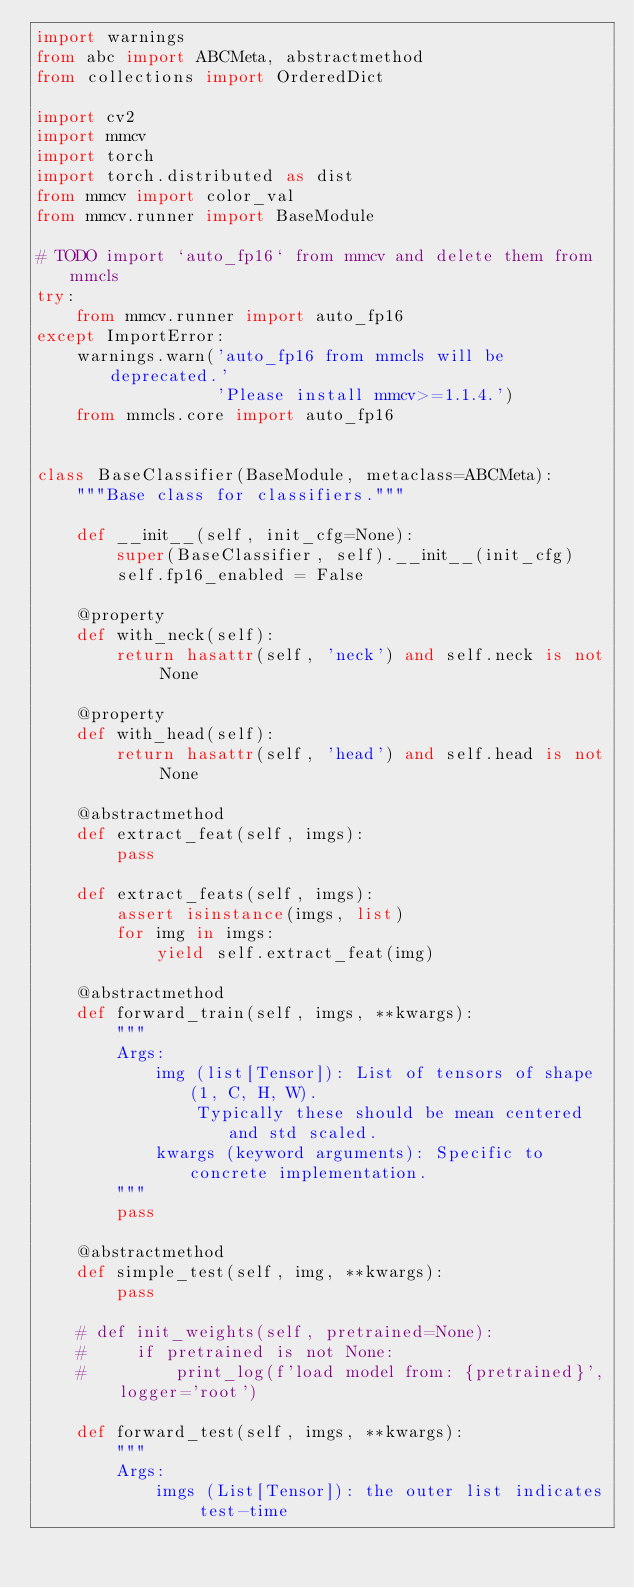<code> <loc_0><loc_0><loc_500><loc_500><_Python_>import warnings
from abc import ABCMeta, abstractmethod
from collections import OrderedDict

import cv2
import mmcv
import torch
import torch.distributed as dist
from mmcv import color_val
from mmcv.runner import BaseModule

# TODO import `auto_fp16` from mmcv and delete them from mmcls
try:
    from mmcv.runner import auto_fp16
except ImportError:
    warnings.warn('auto_fp16 from mmcls will be deprecated.'
                  'Please install mmcv>=1.1.4.')
    from mmcls.core import auto_fp16


class BaseClassifier(BaseModule, metaclass=ABCMeta):
    """Base class for classifiers."""

    def __init__(self, init_cfg=None):
        super(BaseClassifier, self).__init__(init_cfg)
        self.fp16_enabled = False

    @property
    def with_neck(self):
        return hasattr(self, 'neck') and self.neck is not None

    @property
    def with_head(self):
        return hasattr(self, 'head') and self.head is not None

    @abstractmethod
    def extract_feat(self, imgs):
        pass

    def extract_feats(self, imgs):
        assert isinstance(imgs, list)
        for img in imgs:
            yield self.extract_feat(img)

    @abstractmethod
    def forward_train(self, imgs, **kwargs):
        """
        Args:
            img (list[Tensor]): List of tensors of shape (1, C, H, W).
                Typically these should be mean centered and std scaled.
            kwargs (keyword arguments): Specific to concrete implementation.
        """
        pass

    @abstractmethod
    def simple_test(self, img, **kwargs):
        pass

    # def init_weights(self, pretrained=None):
    #     if pretrained is not None:
    #         print_log(f'load model from: {pretrained}', logger='root')

    def forward_test(self, imgs, **kwargs):
        """
        Args:
            imgs (List[Tensor]): the outer list indicates test-time</code> 